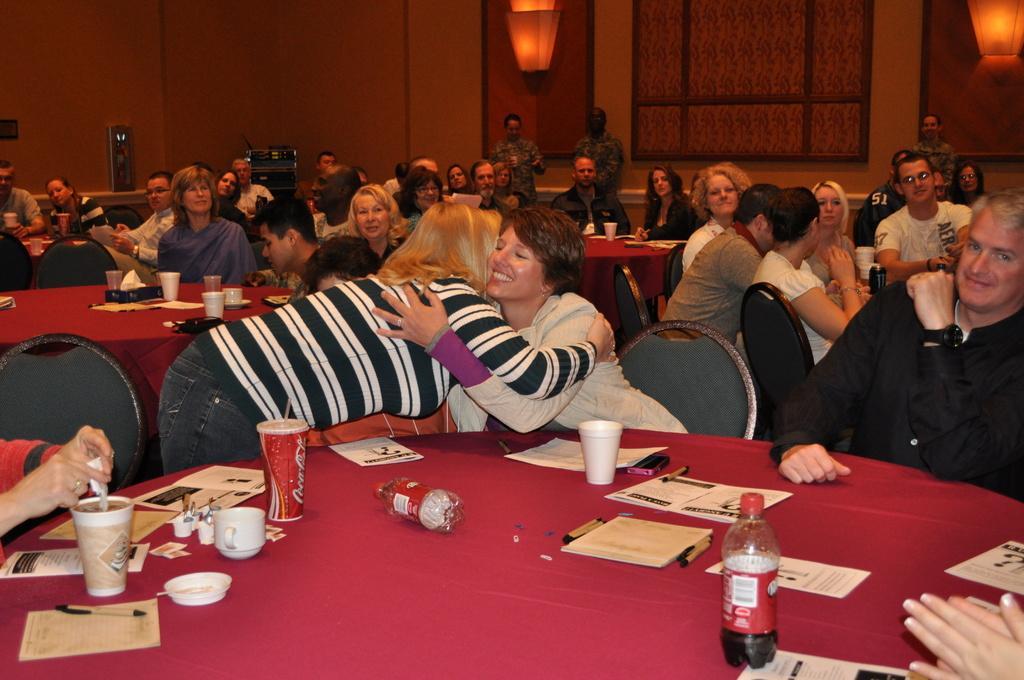In one or two sentences, can you explain what this image depicts? Here we can see all the persons sitting on chairs in front of a table. These two women are greeting to each other. On the table we can see tissuebox, papers, pens, cups, drinking glasses. bottles. These are lights. We can see three persons standing here. These are devices. 